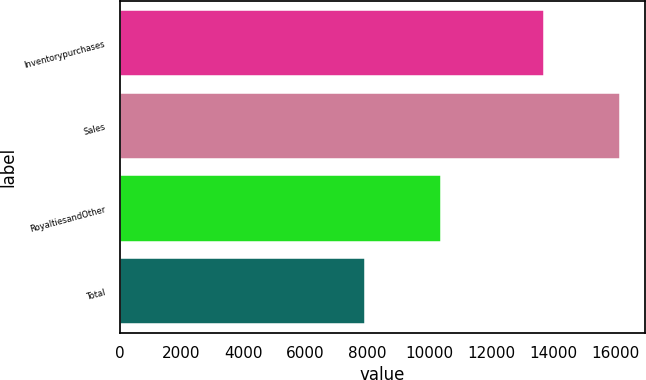Convert chart to OTSL. <chart><loc_0><loc_0><loc_500><loc_500><bar_chart><fcel>Inventorypurchases<fcel>Sales<fcel>RoyaltiesandOther<fcel>Total<nl><fcel>13695<fcel>16144<fcel>10383<fcel>7934<nl></chart> 